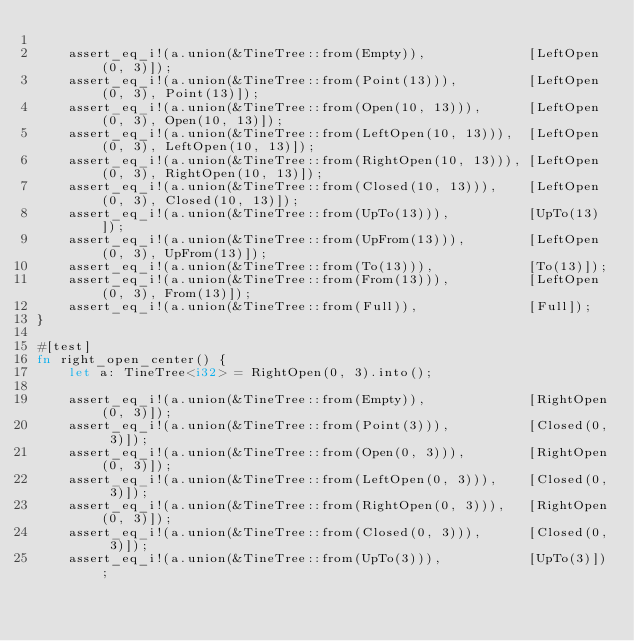<code> <loc_0><loc_0><loc_500><loc_500><_Rust_>
    assert_eq_i!(a.union(&TineTree::from(Empty)),             [LeftOpen(0, 3)]);
    assert_eq_i!(a.union(&TineTree::from(Point(13))),         [LeftOpen(0, 3), Point(13)]);
    assert_eq_i!(a.union(&TineTree::from(Open(10, 13))),      [LeftOpen(0, 3), Open(10, 13)]);
    assert_eq_i!(a.union(&TineTree::from(LeftOpen(10, 13))),  [LeftOpen(0, 3), LeftOpen(10, 13)]);
    assert_eq_i!(a.union(&TineTree::from(RightOpen(10, 13))), [LeftOpen(0, 3), RightOpen(10, 13)]);
    assert_eq_i!(a.union(&TineTree::from(Closed(10, 13))),    [LeftOpen(0, 3), Closed(10, 13)]);
    assert_eq_i!(a.union(&TineTree::from(UpTo(13))),          [UpTo(13)]);
    assert_eq_i!(a.union(&TineTree::from(UpFrom(13))),        [LeftOpen(0, 3), UpFrom(13)]);
    assert_eq_i!(a.union(&TineTree::from(To(13))),            [To(13)]);
    assert_eq_i!(a.union(&TineTree::from(From(13))),          [LeftOpen(0, 3), From(13)]);
    assert_eq_i!(a.union(&TineTree::from(Full)),              [Full]);
}

#[test]
fn right_open_center() {
    let a: TineTree<i32> = RightOpen(0, 3).into();

    assert_eq_i!(a.union(&TineTree::from(Empty)),             [RightOpen(0, 3)]);
    assert_eq_i!(a.union(&TineTree::from(Point(3))),          [Closed(0, 3)]);
    assert_eq_i!(a.union(&TineTree::from(Open(0, 3))),        [RightOpen(0, 3)]);
    assert_eq_i!(a.union(&TineTree::from(LeftOpen(0, 3))),    [Closed(0, 3)]);
    assert_eq_i!(a.union(&TineTree::from(RightOpen(0, 3))),   [RightOpen(0, 3)]);
    assert_eq_i!(a.union(&TineTree::from(Closed(0, 3))),      [Closed(0, 3)]);
    assert_eq_i!(a.union(&TineTree::from(UpTo(3))),           [UpTo(3)]);</code> 